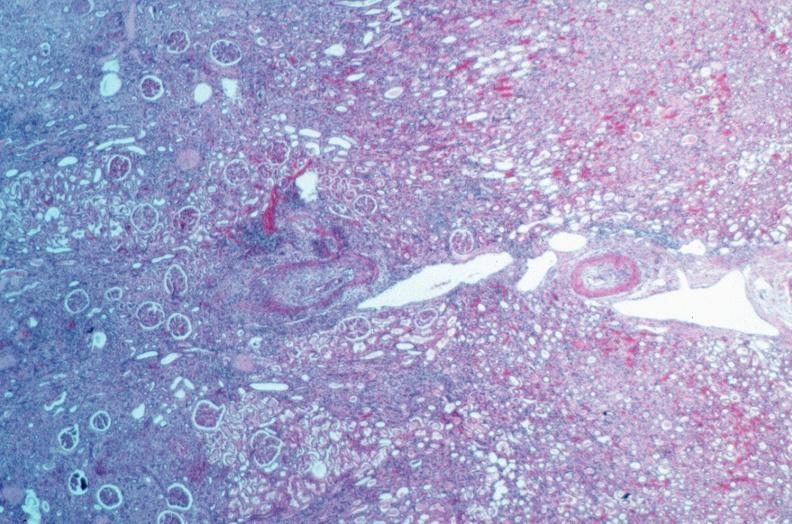s macerated stillborn present?
Answer the question using a single word or phrase. No 